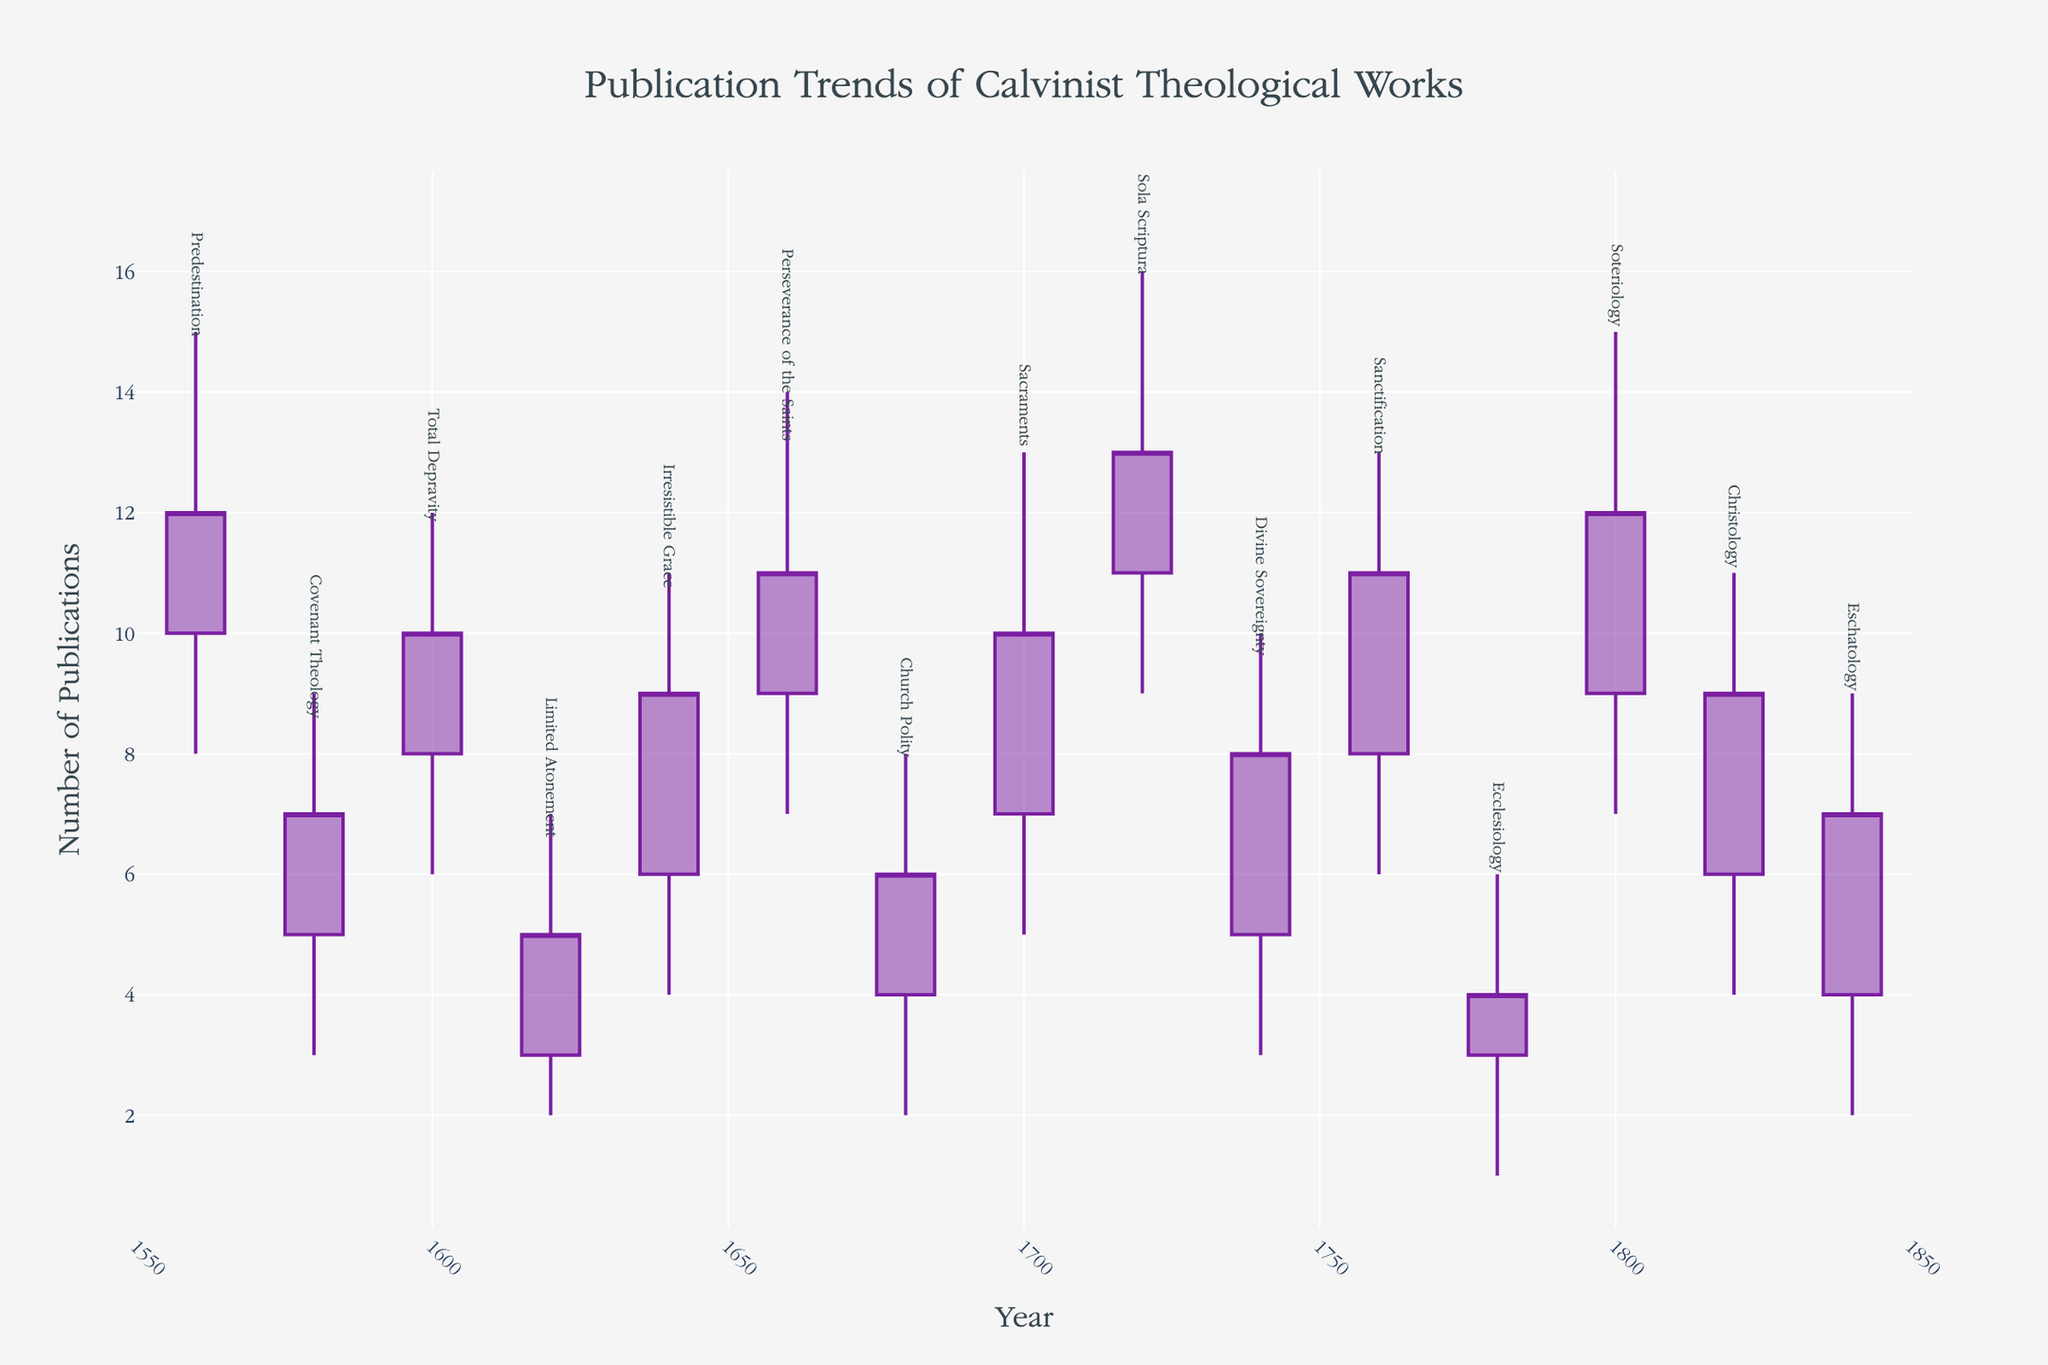How many years are represented in the figure? Count the number of different years on the x-axis, which depicts the dates from 1560 to 1840.
Answer: 15 What is the highest publication count recorded and in which topic? Look at the highest values for each sub-topic (the 'High' values) and find the maximum. The topic corresponding to this maximum is 'Sola Scriptura' with a high value of 16.
Answer: 16, Sola Scriptura Which topic shows the greatest range of publication counts (from lowest to highest)? Calculate the range for each topic by subtracting the 'Low' value from the 'High' value, then identify the topic with the largest range. 'Sanctification' has a high value of 13 and a low value of 6, giving the greatest range of 7.
Answer: Sanctification How many topics had their 'Close' values higher than their 'Open' values? Compare the 'Open' and 'Close' values for each topic and count the number of topics where 'Close' is greater than 'Open'. Topics include 'Predestination', 'Total Depravity', 'Irresistible Grace', 'Perseverance of the Saints', 'Sacraments', 'Sola Scriptura', 'Sanctification', and 'Soteriology'.
Answer: 8 Which topics had a 'Close' value equal to their 'Open' value? Examine each topic's 'Open' and 'Close' values to determine if they are the same. There are no topics with equal 'Open' and 'Close' values.
Answer: None What is the average 'High' value of all the topics combined? Add up all the 'High' values and divide by the number of topics to get the average. The total 'High' values are 15 + 9 + 12 + 7 + 11 + 14 + 8 + 13 + 16 + 10 + 13 + 6 + 15 + 11 + 9 = 169. There are 15 topics, so the average is 169 / 15 = 11.27.
Answer: 11.27 Which topic had the smallest difference between the 'Open' and 'Close' values? Calculate the difference for each topic by subtracting the 'Open' value from the 'Close' value and determining the smallest difference. 'Covenant Theology' had an 'Open' of 5 and Close of 7, giving the smallest difference of 2.
Answer: Covenant Theology During which two consecutive periods was there the greatest increase in publication counts for any single topic? Look at consecutive periods for each topic, compare 'Close' of one period to 'Open' of the following period, and find the greatest increase. 'Sacraments' from 1640 to 1660 went from 'Close' of 7 to 'Open' of 9, an increase of 2.
Answer: 1640-1660 for 'Perseverance of the Saints' Which topic has the highest minimum (lowest low) publication count? Identify the topic with the highest 'Low' value. 'Sola Scriptura' has the highest 'Low' value at 9.
Answer: Sola Scriptura 